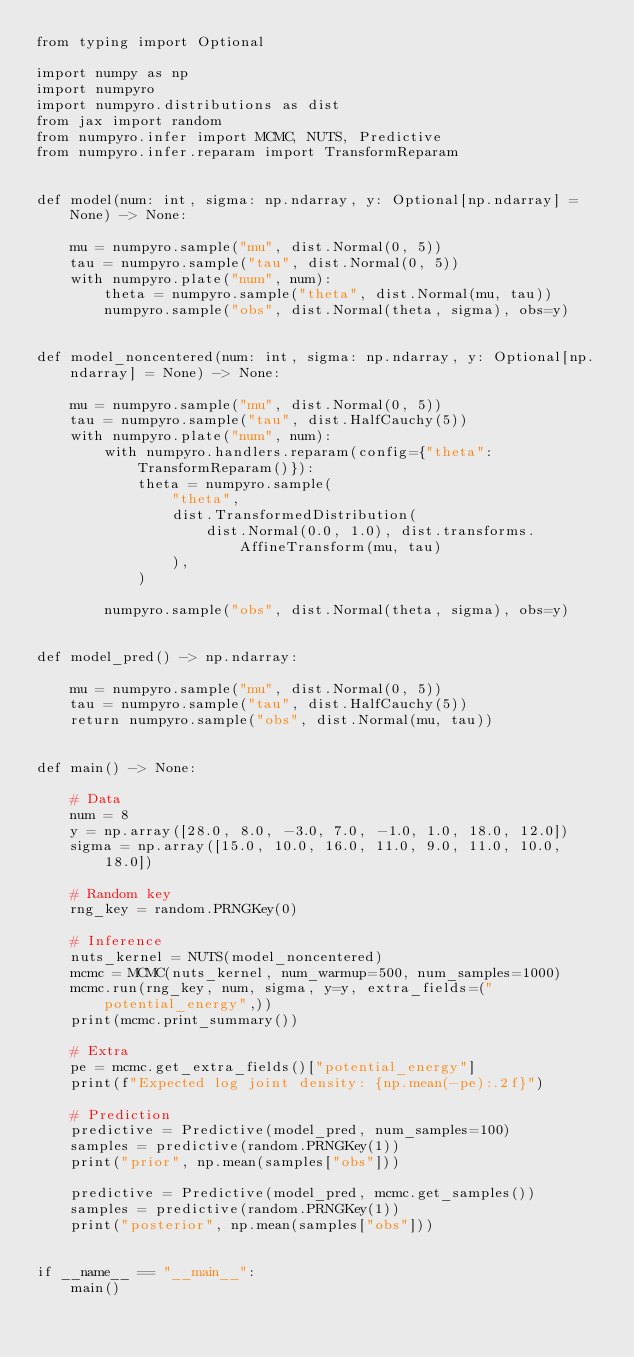<code> <loc_0><loc_0><loc_500><loc_500><_Python_>from typing import Optional

import numpy as np
import numpyro
import numpyro.distributions as dist
from jax import random
from numpyro.infer import MCMC, NUTS, Predictive
from numpyro.infer.reparam import TransformReparam


def model(num: int, sigma: np.ndarray, y: Optional[np.ndarray] = None) -> None:

    mu = numpyro.sample("mu", dist.Normal(0, 5))
    tau = numpyro.sample("tau", dist.Normal(0, 5))
    with numpyro.plate("num", num):
        theta = numpyro.sample("theta", dist.Normal(mu, tau))
        numpyro.sample("obs", dist.Normal(theta, sigma), obs=y)


def model_noncentered(num: int, sigma: np.ndarray, y: Optional[np.ndarray] = None) -> None:

    mu = numpyro.sample("mu", dist.Normal(0, 5))
    tau = numpyro.sample("tau", dist.HalfCauchy(5))
    with numpyro.plate("num", num):
        with numpyro.handlers.reparam(config={"theta": TransformReparam()}):
            theta = numpyro.sample(
                "theta",
                dist.TransformedDistribution(
                    dist.Normal(0.0, 1.0), dist.transforms.AffineTransform(mu, tau)
                ),
            )

        numpyro.sample("obs", dist.Normal(theta, sigma), obs=y)


def model_pred() -> np.ndarray:

    mu = numpyro.sample("mu", dist.Normal(0, 5))
    tau = numpyro.sample("tau", dist.HalfCauchy(5))
    return numpyro.sample("obs", dist.Normal(mu, tau))


def main() -> None:

    # Data
    num = 8
    y = np.array([28.0, 8.0, -3.0, 7.0, -1.0, 1.0, 18.0, 12.0])
    sigma = np.array([15.0, 10.0, 16.0, 11.0, 9.0, 11.0, 10.0, 18.0])

    # Random key
    rng_key = random.PRNGKey(0)

    # Inference
    nuts_kernel = NUTS(model_noncentered)
    mcmc = MCMC(nuts_kernel, num_warmup=500, num_samples=1000)
    mcmc.run(rng_key, num, sigma, y=y, extra_fields=("potential_energy",))
    print(mcmc.print_summary())

    # Extra
    pe = mcmc.get_extra_fields()["potential_energy"]
    print(f"Expected log joint density: {np.mean(-pe):.2f}")

    # Prediction
    predictive = Predictive(model_pred, num_samples=100)
    samples = predictive(random.PRNGKey(1))
    print("prior", np.mean(samples["obs"]))

    predictive = Predictive(model_pred, mcmc.get_samples())
    samples = predictive(random.PRNGKey(1))
    print("posterior", np.mean(samples["obs"]))


if __name__ == "__main__":
    main()
</code> 